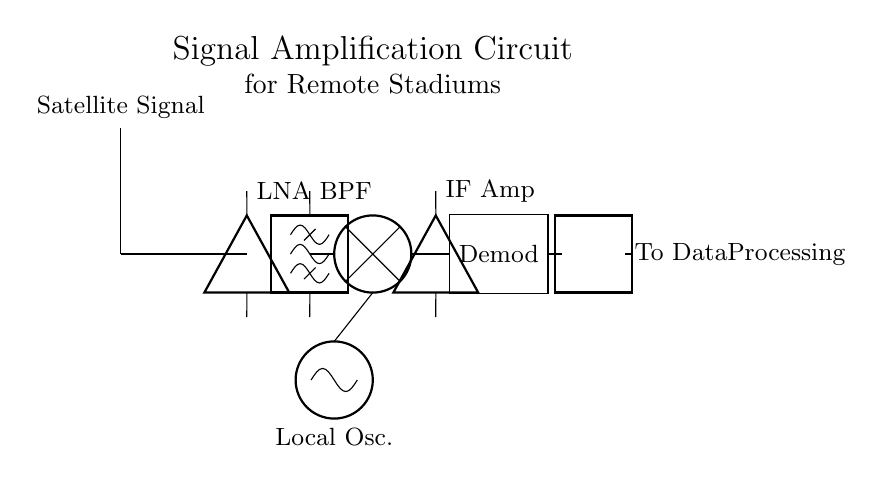what component is used for amplifying the signal? The circuit uses a Low Noise Amplifier (LNA) for amplifying the satellite signal, which is typically necessary for boosting weak signals before further processing.
Answer: Low Noise Amplifier what does BPF stand for? BPF stands for Bandpass Filter, which allows signals within a certain frequency range to pass while attenuating those outside that range.
Answer: Bandpass Filter how many total components are there in the circuit? Counting the significant components: antenna, LNA, BPF, mixer, local oscillator, IF amplifier, and demodulator gives a total of 7 components in the circuit.
Answer: 7 what is the primary function of the mixer in this circuit? The primary function of the mixer in this circuit is to combine the incoming radio frequency signal with a local oscillator signal to produce an intermediate frequency, which is lower and easier to process.
Answer: Combine signals which component connects the LNA to the bandpass filter? The connection is established through a short wire that directly links the output of the Low Noise Amplifier to the input of the Bandpass Filter.
Answer: Short wire what is the final output of the circuit? The final output of the circuit is directed to data processing, where the demodulated signals can be interpreted and utilized effectively.
Answer: To Data Processing what is the role of the local oscillator in this circuit? The local oscillator generates a stable reference frequency to mix with the incoming signal in the mixer, facilitating the generation of an intermediate frequency for better signal processing.
Answer: Generate reference frequency 